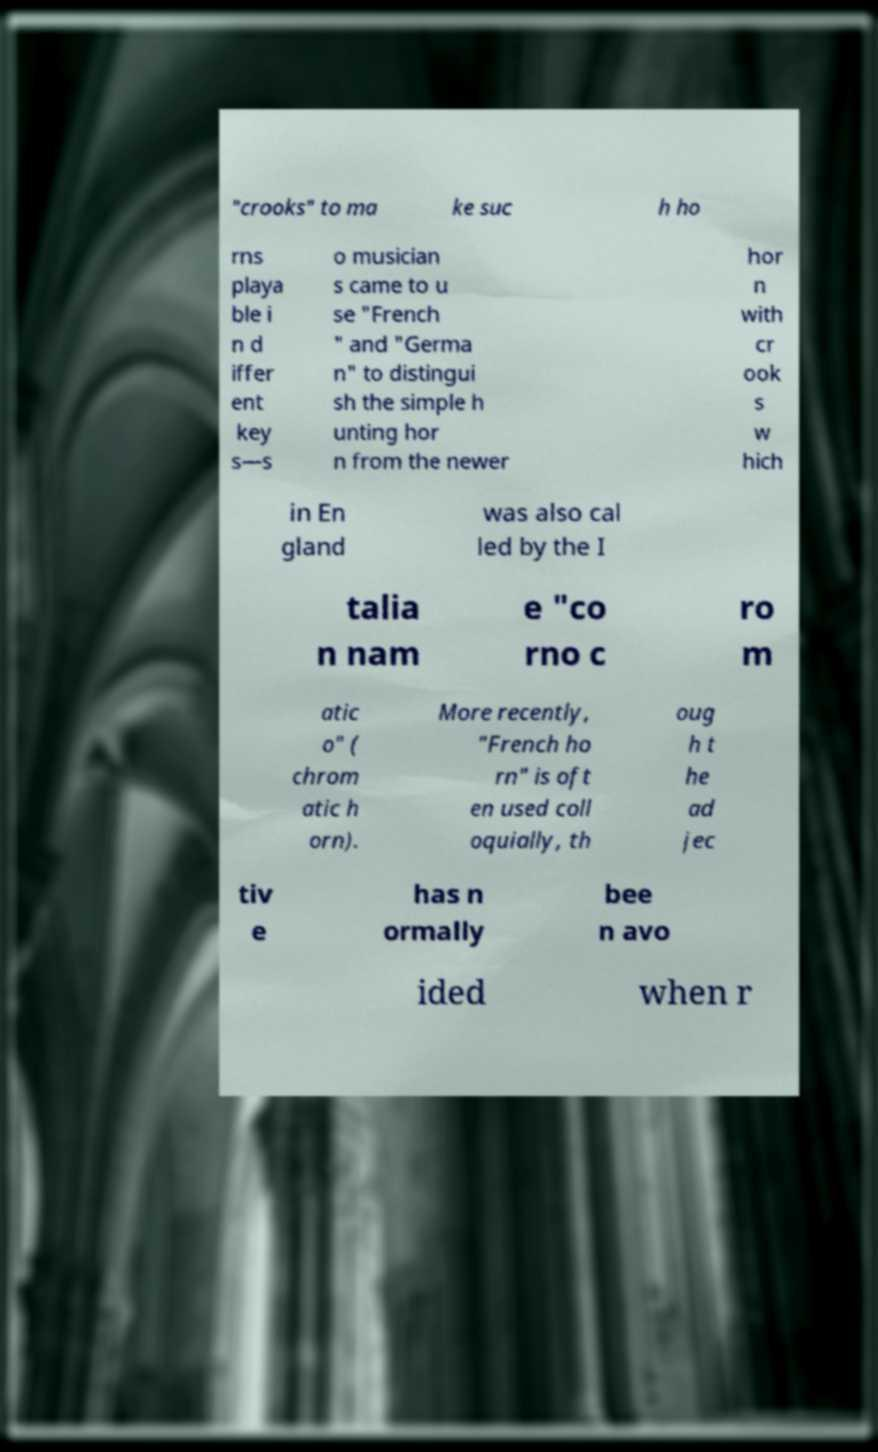Could you assist in decoding the text presented in this image and type it out clearly? "crooks" to ma ke suc h ho rns playa ble i n d iffer ent key s—s o musician s came to u se "French " and "Germa n" to distingui sh the simple h unting hor n from the newer hor n with cr ook s w hich in En gland was also cal led by the I talia n nam e "co rno c ro m atic o" ( chrom atic h orn). More recently, "French ho rn" is oft en used coll oquially, th oug h t he ad jec tiv e has n ormally bee n avo ided when r 